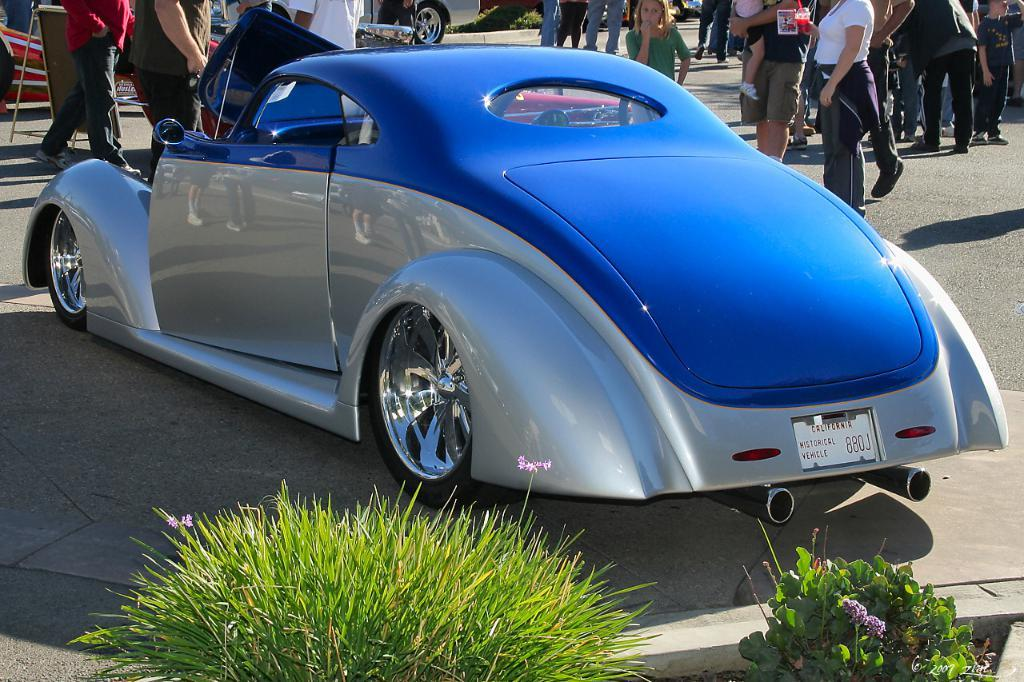What is the main subject of the image? There is a car in the image. What else can be seen in the image besides the car? There are groups of people standing on the road and a vehicle visible in the top corner of the image. What type of vegetation is at the bottom of the image? There are plants at the bottom of the image. What type of glue is being used by the people on the stage in the image? There is no stage or glue present in the image. What sound can be heard coming from the car in the image? The image is static, so no sound can be heard. 